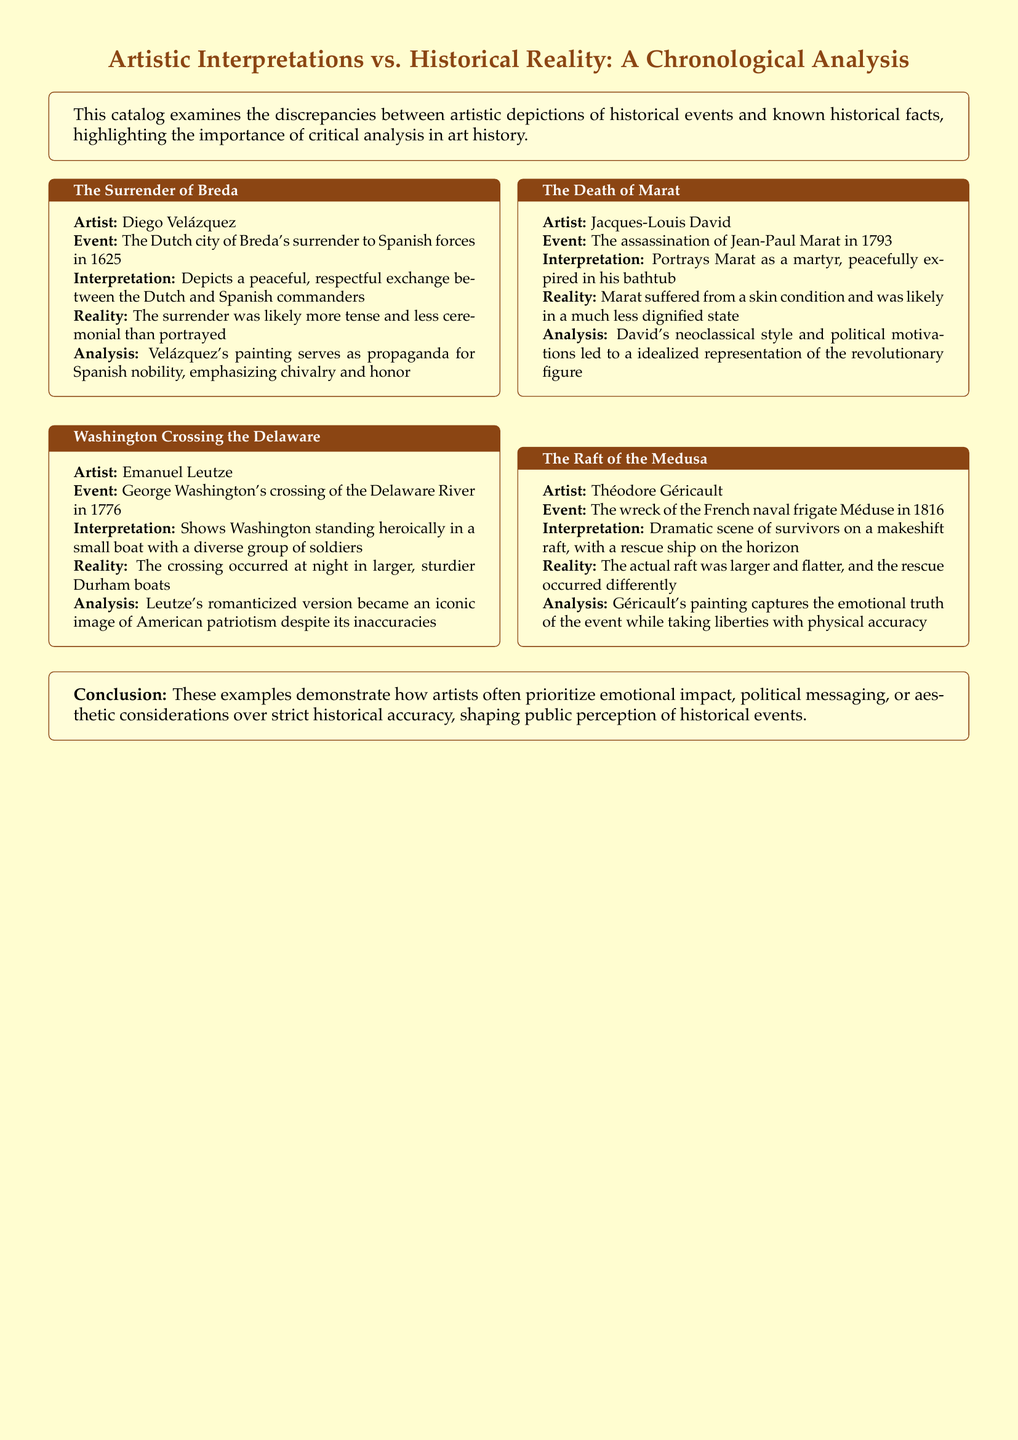What is the title of the first artwork discussed? The title is the name of the first artwork listed in the document, which is "The Surrender of Breda."
Answer: The Surrender of Breda Who is the artist of "Washington Crossing the Delaware"? The artist is identified as Emanuel Leutze, who created the artwork.
Answer: Emanuel Leutze What significant event does "The Death of Marat" depict? The event depicted is the assassination of Jean-Paul Marat, as stated in the document.
Answer: The assassination of Jean-Paul Marat In what year did the incident associated with "The Raft of the Medusa" occur? The document specifies the year of the event related to the artwork, which is 1816.
Answer: 1816 What discrepancy is noted about "Washington Crossing the Delaware"? The document mentions that the crossing occurred at night in larger, sturdier Durham boats, which differs from the painting.
Answer: Night in larger, sturdier Durham boats How does David's portrayal of Marat serve a political purpose? The assertion refers to David's neoclassical style and motivations leading to a glorified representation of Marat, reflecting political ideals.
Answer: Political motivations led to idealized representation What common theme is noted for all artistic interpretations in the document? The theme mentioned refers to the prioritization of emotional impact or political messaging over strict historical accuracy.
Answer: Emotional impact and political messaging What is the primary purpose of this catalog as stated in the document? The catalog's purpose is to critically analyze discrepancies between artistic depictions and historical facts.
Answer: To critically analyze discrepancies 